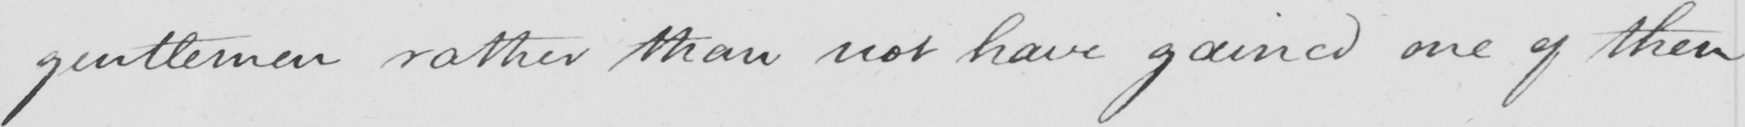Please transcribe the handwritten text in this image. gentlemen rather than not have gained one of them 